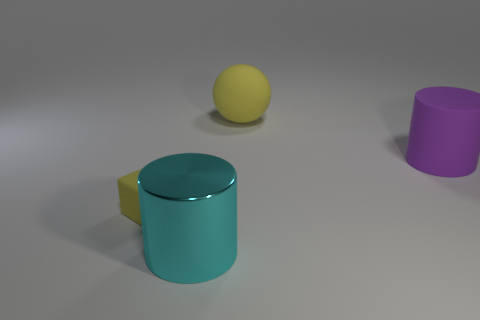How many yellow matte objects are both right of the metallic cylinder and in front of the big yellow matte object?
Give a very brief answer. 0. How many other objects are there of the same size as the yellow rubber sphere?
Your response must be concise. 2. There is a object that is behind the large metallic cylinder and left of the big matte sphere; what material is it made of?
Provide a succinct answer. Rubber. Does the rubber cylinder have the same color as the cylinder that is in front of the tiny yellow matte cube?
Keep it short and to the point. No. The other object that is the same shape as the purple thing is what size?
Make the answer very short. Large. What is the shape of the matte thing that is to the left of the purple matte thing and to the right of the tiny yellow cube?
Your answer should be very brief. Sphere. Is the size of the block the same as the cylinder to the left of the matte cylinder?
Give a very brief answer. No. What is the color of the rubber thing that is the same shape as the metal object?
Make the answer very short. Purple. Is the size of the matte object that is behind the matte cylinder the same as the object that is in front of the tiny yellow cube?
Your answer should be very brief. Yes. Is the shape of the purple thing the same as the cyan object?
Make the answer very short. Yes. 